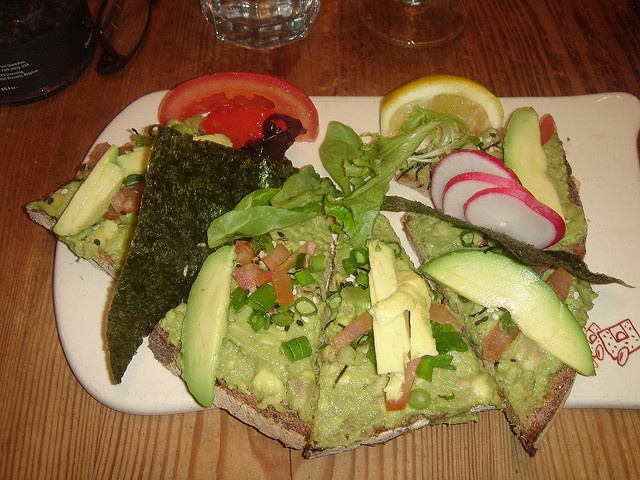Describe the objects in this image and their specific colors. I can see sandwich in black, olive, and khaki tones, dining table in black, maroon, brown, and gray tones, pizza in black and olive tones, pizza in black, olive, and khaki tones, and pizza in black, olive, and khaki tones in this image. 